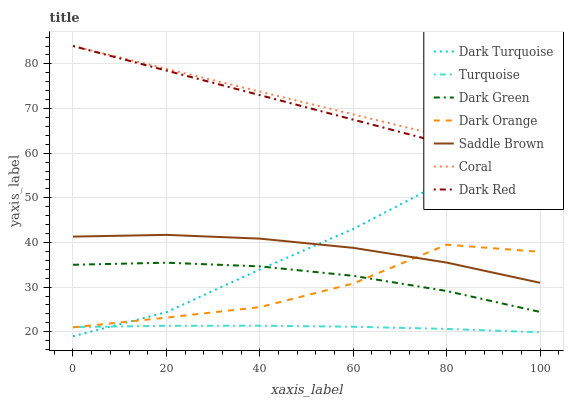Does Dark Turquoise have the minimum area under the curve?
Answer yes or no. No. Does Dark Turquoise have the maximum area under the curve?
Answer yes or no. No. Is Turquoise the smoothest?
Answer yes or no. No. Is Turquoise the roughest?
Answer yes or no. No. Does Turquoise have the lowest value?
Answer yes or no. No. Does Dark Turquoise have the highest value?
Answer yes or no. No. Is Turquoise less than Coral?
Answer yes or no. Yes. Is Dark Red greater than Dark Green?
Answer yes or no. Yes. Does Turquoise intersect Coral?
Answer yes or no. No. 